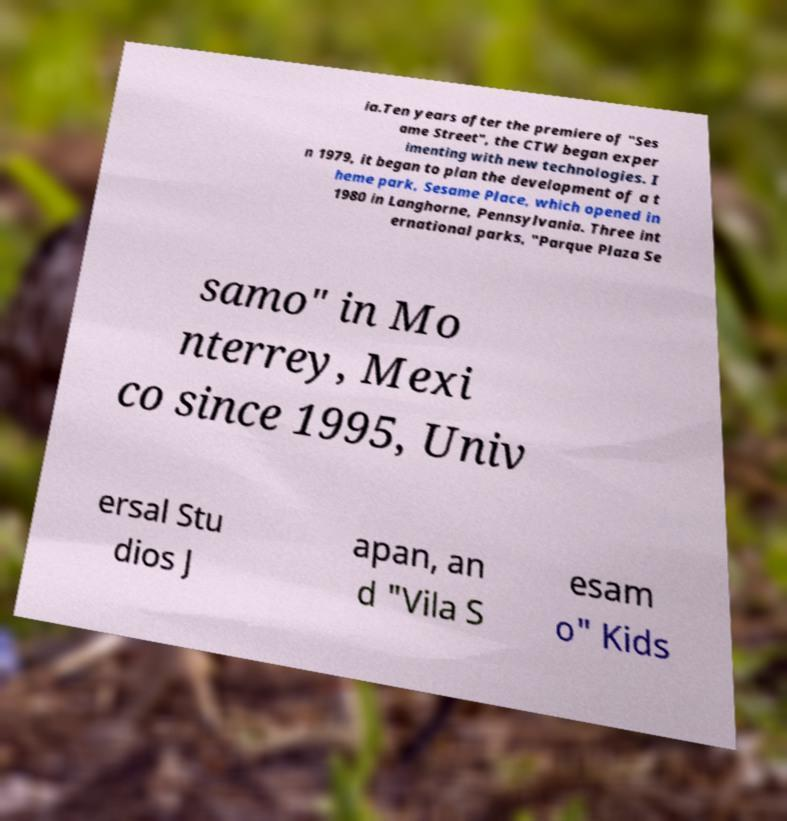There's text embedded in this image that I need extracted. Can you transcribe it verbatim? ia.Ten years after the premiere of "Ses ame Street", the CTW began exper imenting with new technologies. I n 1979, it began to plan the development of a t heme park, Sesame Place, which opened in 1980 in Langhorne, Pennsylvania. Three int ernational parks, "Parque Plaza Se samo" in Mo nterrey, Mexi co since 1995, Univ ersal Stu dios J apan, an d "Vila S esam o" Kids 